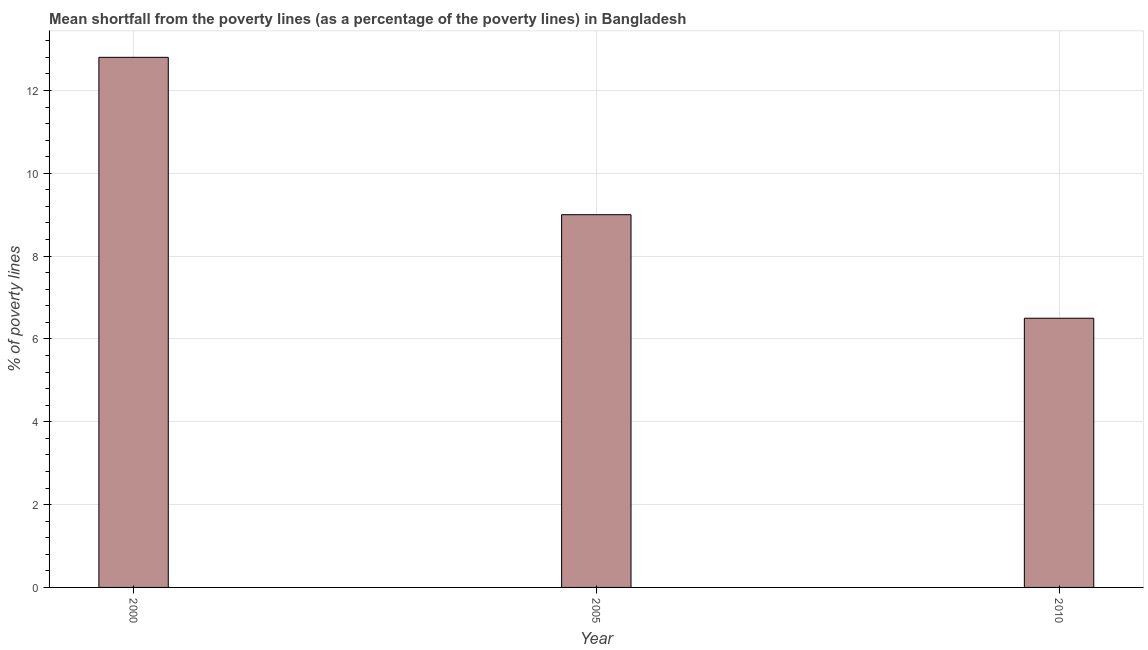Does the graph contain any zero values?
Your answer should be very brief. No. What is the title of the graph?
Make the answer very short. Mean shortfall from the poverty lines (as a percentage of the poverty lines) in Bangladesh. What is the label or title of the Y-axis?
Ensure brevity in your answer.  % of poverty lines. What is the poverty gap at national poverty lines in 2005?
Your answer should be compact. 9. Across all years, what is the maximum poverty gap at national poverty lines?
Your answer should be very brief. 12.8. What is the sum of the poverty gap at national poverty lines?
Give a very brief answer. 28.3. What is the difference between the poverty gap at national poverty lines in 2000 and 2005?
Give a very brief answer. 3.8. What is the average poverty gap at national poverty lines per year?
Ensure brevity in your answer.  9.43. Do a majority of the years between 2010 and 2005 (inclusive) have poverty gap at national poverty lines greater than 0.4 %?
Your response must be concise. No. What is the ratio of the poverty gap at national poverty lines in 2000 to that in 2010?
Make the answer very short. 1.97. What is the difference between the highest and the second highest poverty gap at national poverty lines?
Offer a very short reply. 3.8. In how many years, is the poverty gap at national poverty lines greater than the average poverty gap at national poverty lines taken over all years?
Keep it short and to the point. 1. How many bars are there?
Give a very brief answer. 3. What is the % of poverty lines of 2005?
Ensure brevity in your answer.  9. What is the difference between the % of poverty lines in 2005 and 2010?
Provide a short and direct response. 2.5. What is the ratio of the % of poverty lines in 2000 to that in 2005?
Give a very brief answer. 1.42. What is the ratio of the % of poverty lines in 2000 to that in 2010?
Provide a short and direct response. 1.97. What is the ratio of the % of poverty lines in 2005 to that in 2010?
Offer a terse response. 1.39. 